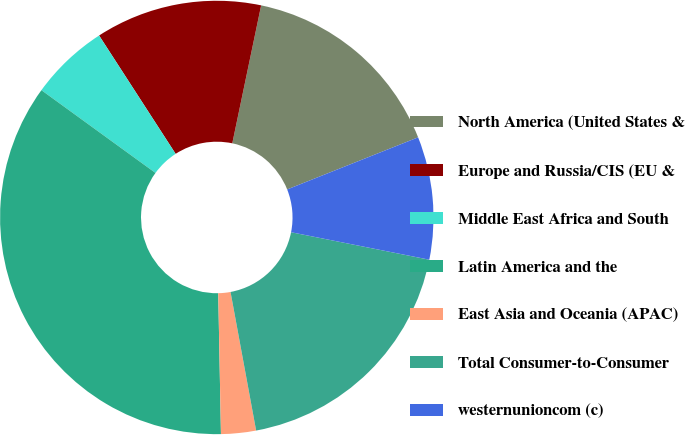Convert chart. <chart><loc_0><loc_0><loc_500><loc_500><pie_chart><fcel>North America (United States &<fcel>Europe and Russia/CIS (EU &<fcel>Middle East Africa and South<fcel>Latin America and the<fcel>East Asia and Oceania (APAC)<fcel>Total Consumer-to-Consumer<fcel>westernunioncom (c)<nl><fcel>15.69%<fcel>12.42%<fcel>5.87%<fcel>35.3%<fcel>2.6%<fcel>18.97%<fcel>9.15%<nl></chart> 